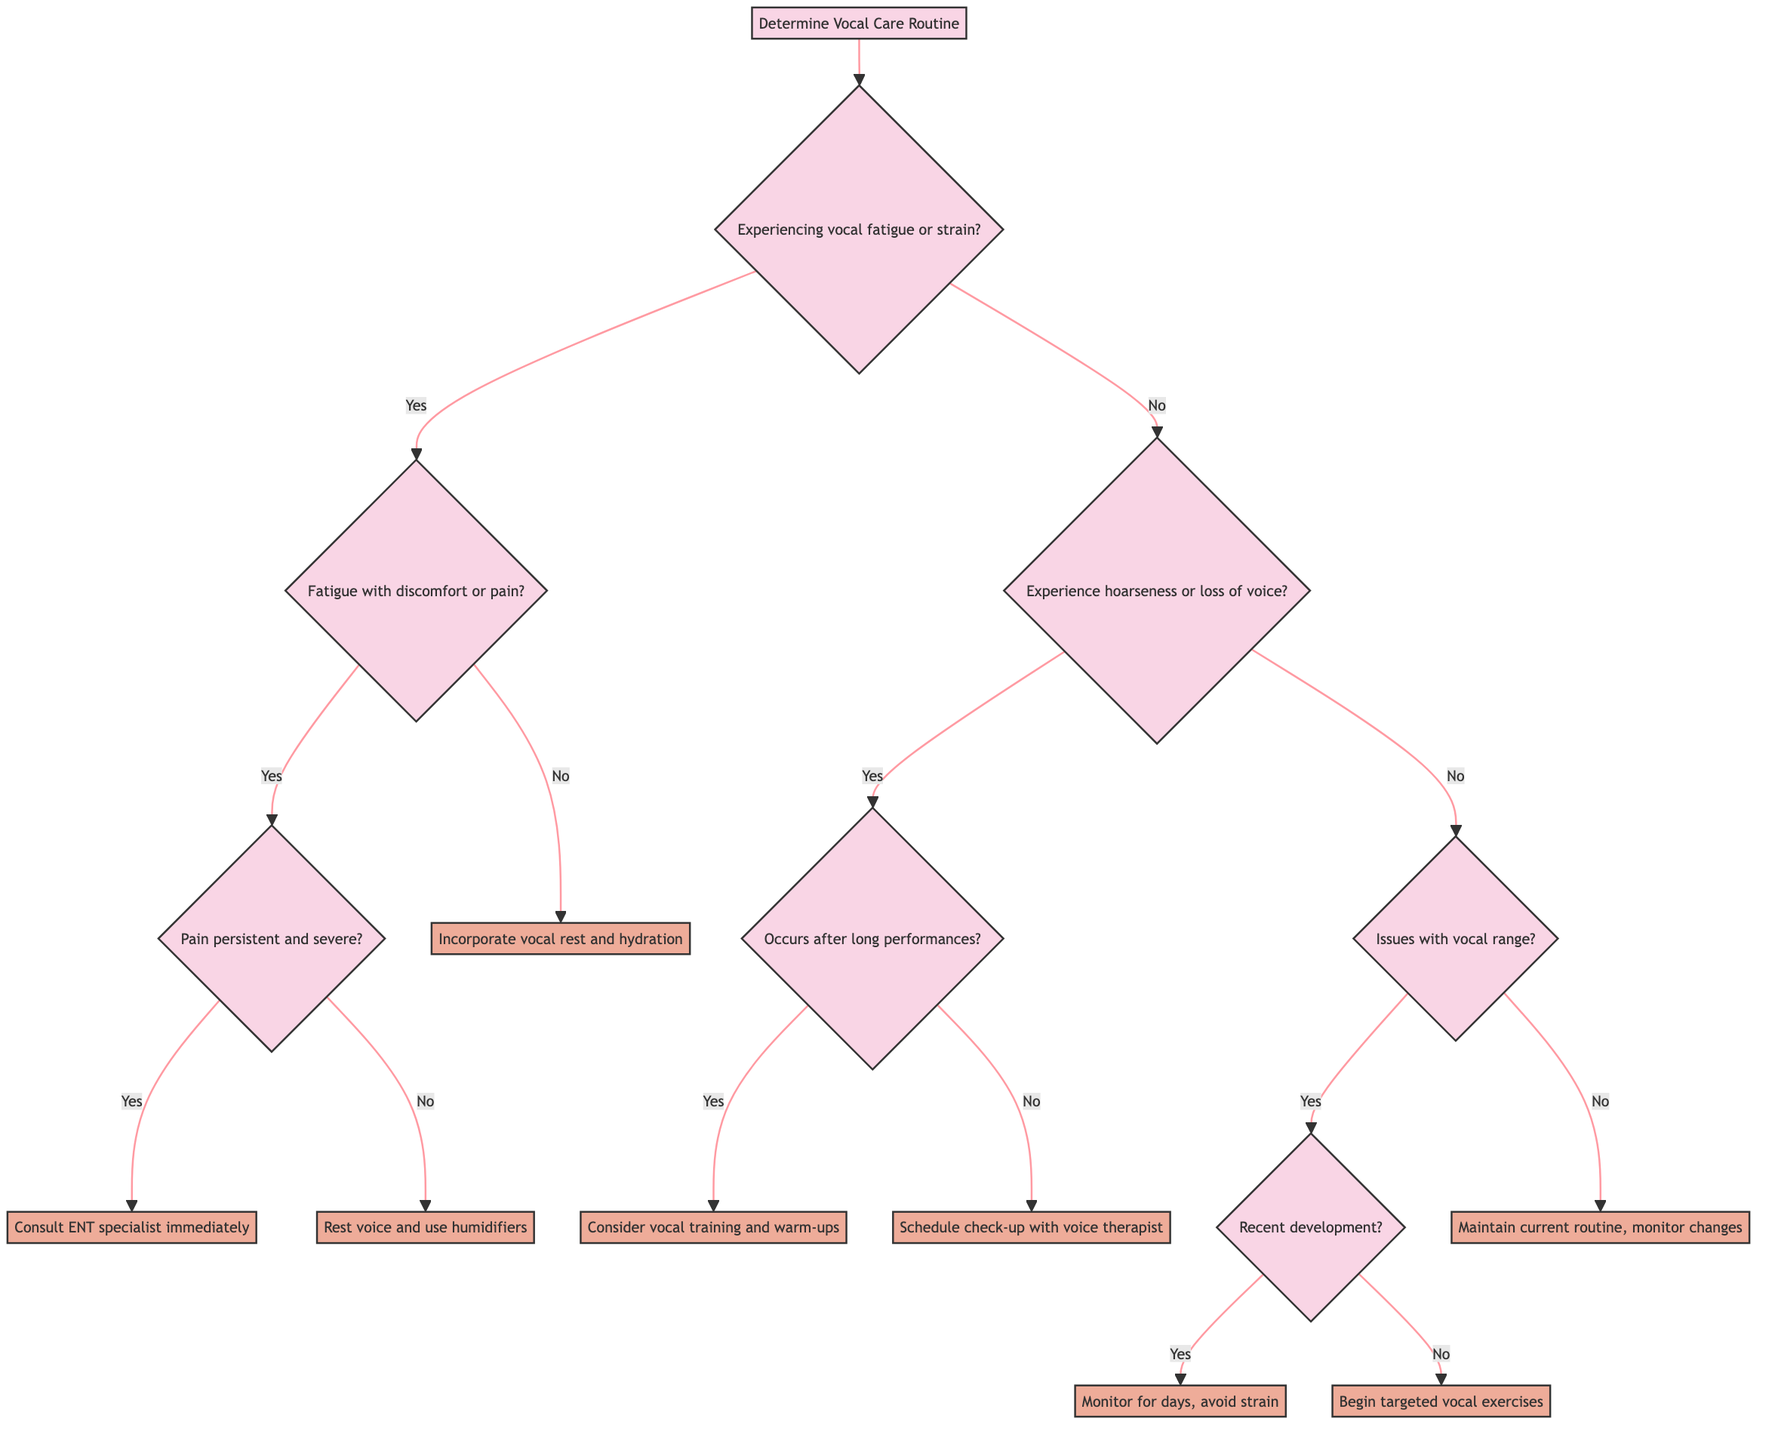What are the two main categories of vocal issues identified in the diagram? The diagram categorizes vocal issues into two main types based on the first question: "Are you experiencing vocal fatigue or strain?" The first category relates to vocal fatigue/strain, and the second category relates to hoarseness/loss of voice.
Answer: Fatigue/strain and hoarseness/loss of voice What action is recommended if pain is persistent and severe? According to the diagram, if the fatigue is accompanied by discomfort or pain, and that pain is persistent and severe, the recommended action is to "Consult an ENT specialist immediately."
Answer: Consult an ENT specialist immediately How many nodes lead to an action in the case of experiencing hoarseness? Starting from the hoarseness question, there are three resulting actions depending on further answers: "Consider vocal training and warm-ups," "Schedule check-up with a voice therapist," and "Maintain your current vocal care routine." Summing these decisions gives a total of three action nodes.
Answer: Three action nodes If someone is experiencing vocal fatigue without pain, what should they do? The diagram specifies that if there is vocal fatigue but no discomfort or pain, the action to be taken is to "Incorporate regular vocal rest periods and hydration into your daily routine."
Answer: Incorporate vocal rest and hydration What should one monitor for if they face recent vocal range issues? If a person has issues with their vocal range that have developed recently, the diagram suggests to "Monitor for a few days while avoiding strain; if persistent, consult a specialist." This is a preventive measure before seeking professional help.
Answer: Monitor for a few days, avoid strain 